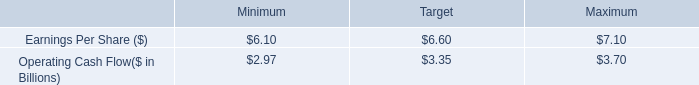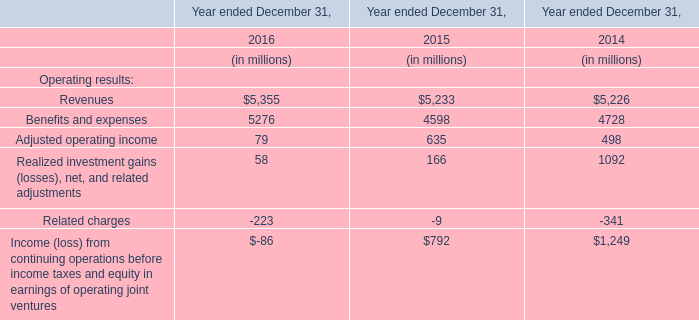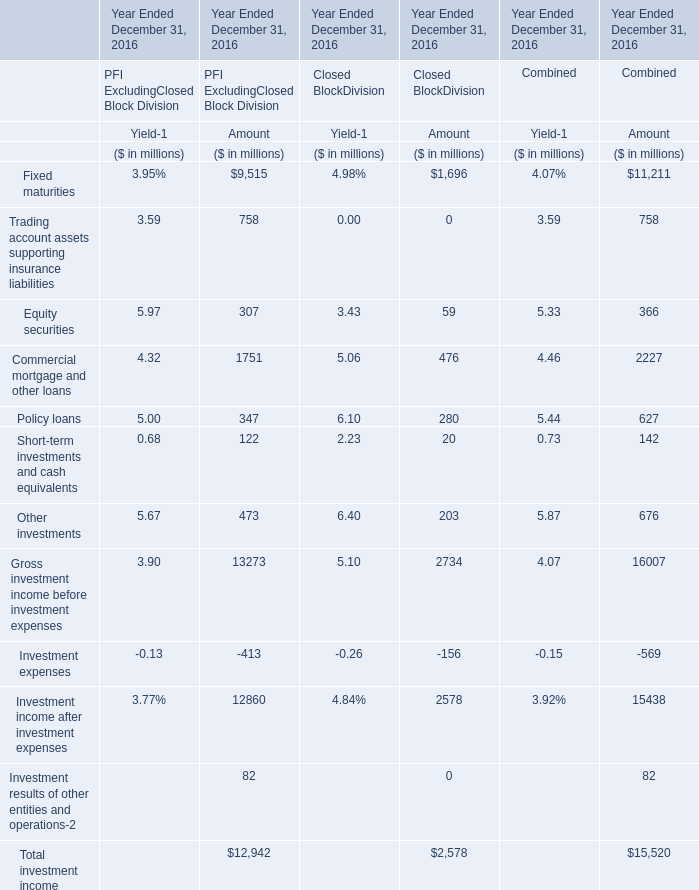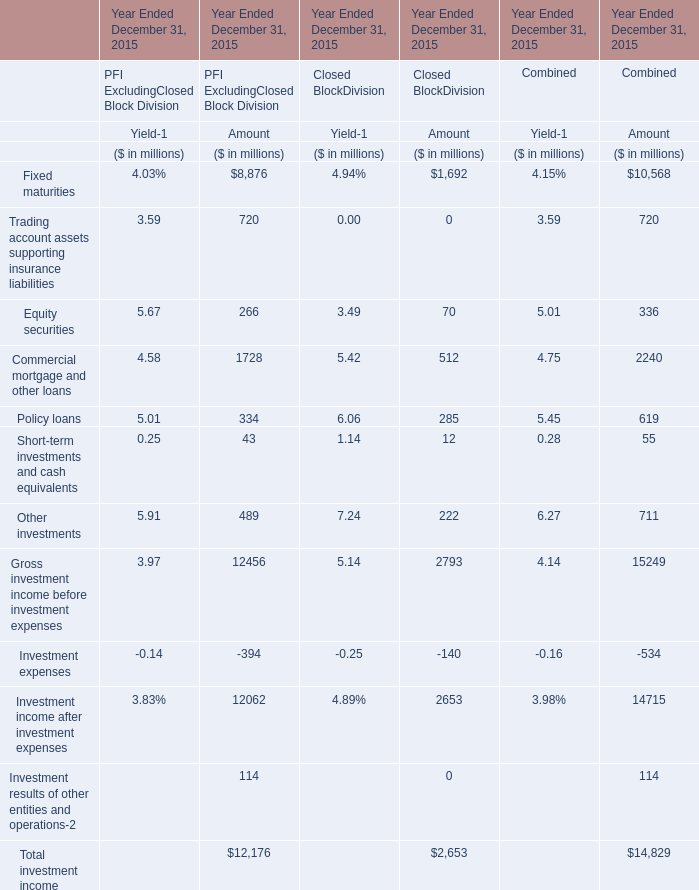In the section with largest amount ofTrading account assets supporting insurance liabilities, what's the sum ofEquity securitie and Commercial mortgage and other loans forPFI ExcludingClosed Block Division (in million) 
Computations: (266 + 1728)
Answer: 1994.0. 